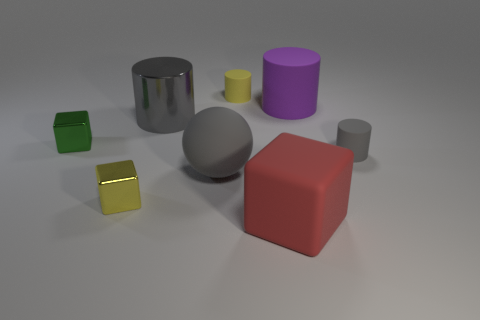There is a cylinder that is the same color as the big shiny object; what size is it?
Your answer should be very brief. Small. What is the shape of the other big thing that is the same color as the big shiny object?
Your response must be concise. Sphere. There is a gray rubber thing that is right of the small yellow cylinder; is there a big matte block behind it?
Offer a terse response. No. Is there another red object that has the same shape as the big red matte object?
Offer a very short reply. No. How many tiny rubber objects are in front of the small yellow thing that is on the left side of the big gray sphere behind the big red object?
Give a very brief answer. 0. Do the big cube and the small rubber cylinder to the right of the large red rubber thing have the same color?
Provide a succinct answer. No. How many things are either cylinders to the left of the yellow rubber cylinder or small things that are right of the big gray cylinder?
Your answer should be very brief. 3. Are there more large gray things in front of the small gray cylinder than large red objects that are behind the small yellow shiny block?
Your answer should be very brief. Yes. What material is the cube that is right of the yellow cube behind the big object in front of the big matte sphere made of?
Offer a very short reply. Rubber. Is the shape of the big rubber thing that is left of the yellow cylinder the same as the large matte thing right of the big red thing?
Ensure brevity in your answer.  No. 